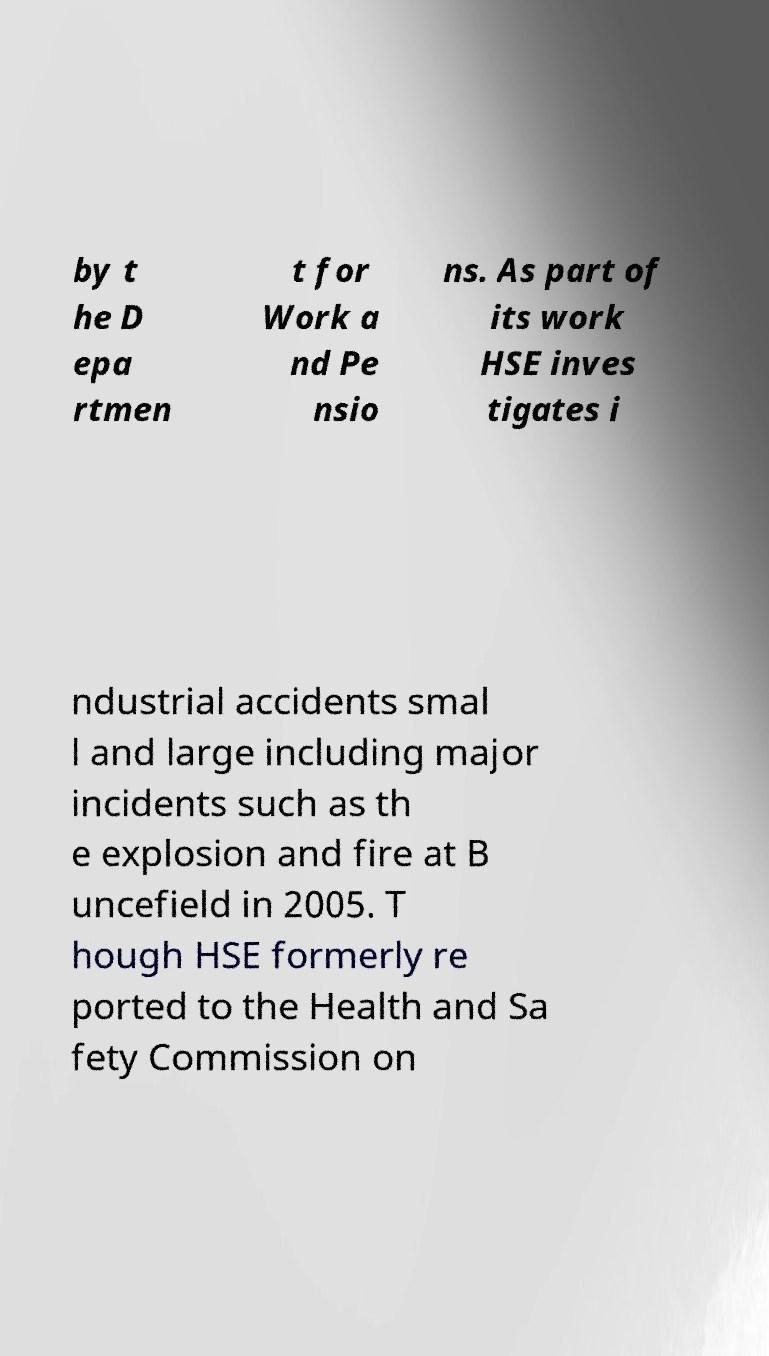Could you assist in decoding the text presented in this image and type it out clearly? by t he D epa rtmen t for Work a nd Pe nsio ns. As part of its work HSE inves tigates i ndustrial accidents smal l and large including major incidents such as th e explosion and fire at B uncefield in 2005. T hough HSE formerly re ported to the Health and Sa fety Commission on 